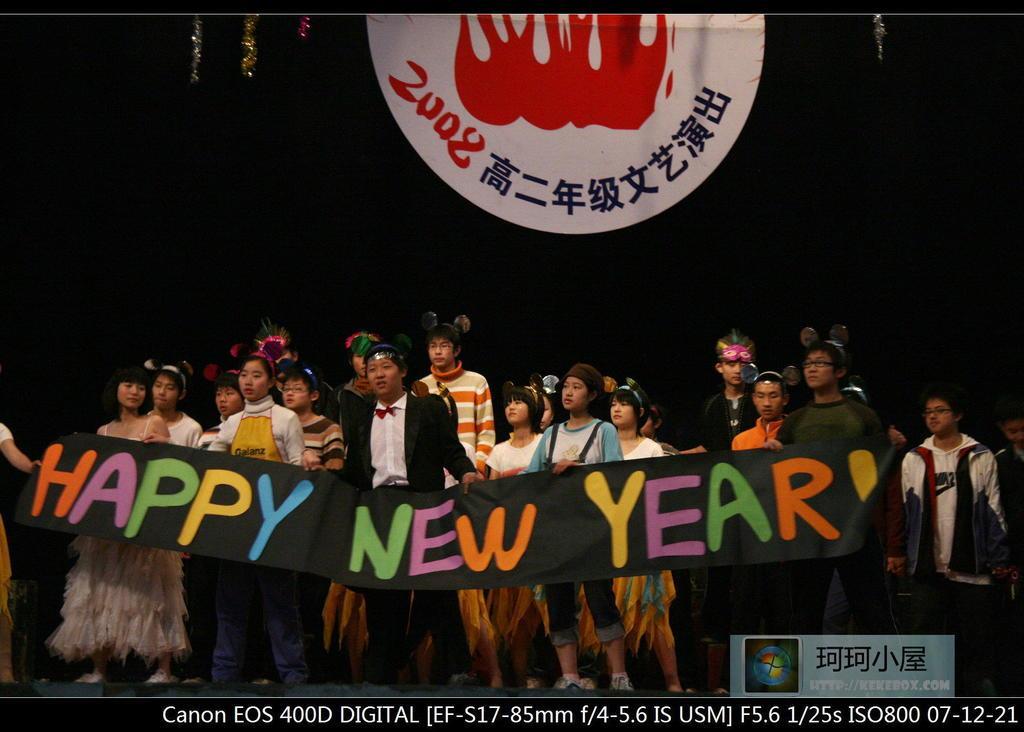Please provide a concise description of this image. In the image we can see there are many people standing, they are wearing clothes and shoes. Here we can see the banner and we can see the text on the banner, and the background is dark. 